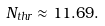Convert formula to latex. <formula><loc_0><loc_0><loc_500><loc_500>N _ { t h r } \approx 1 1 . 6 9 .</formula> 